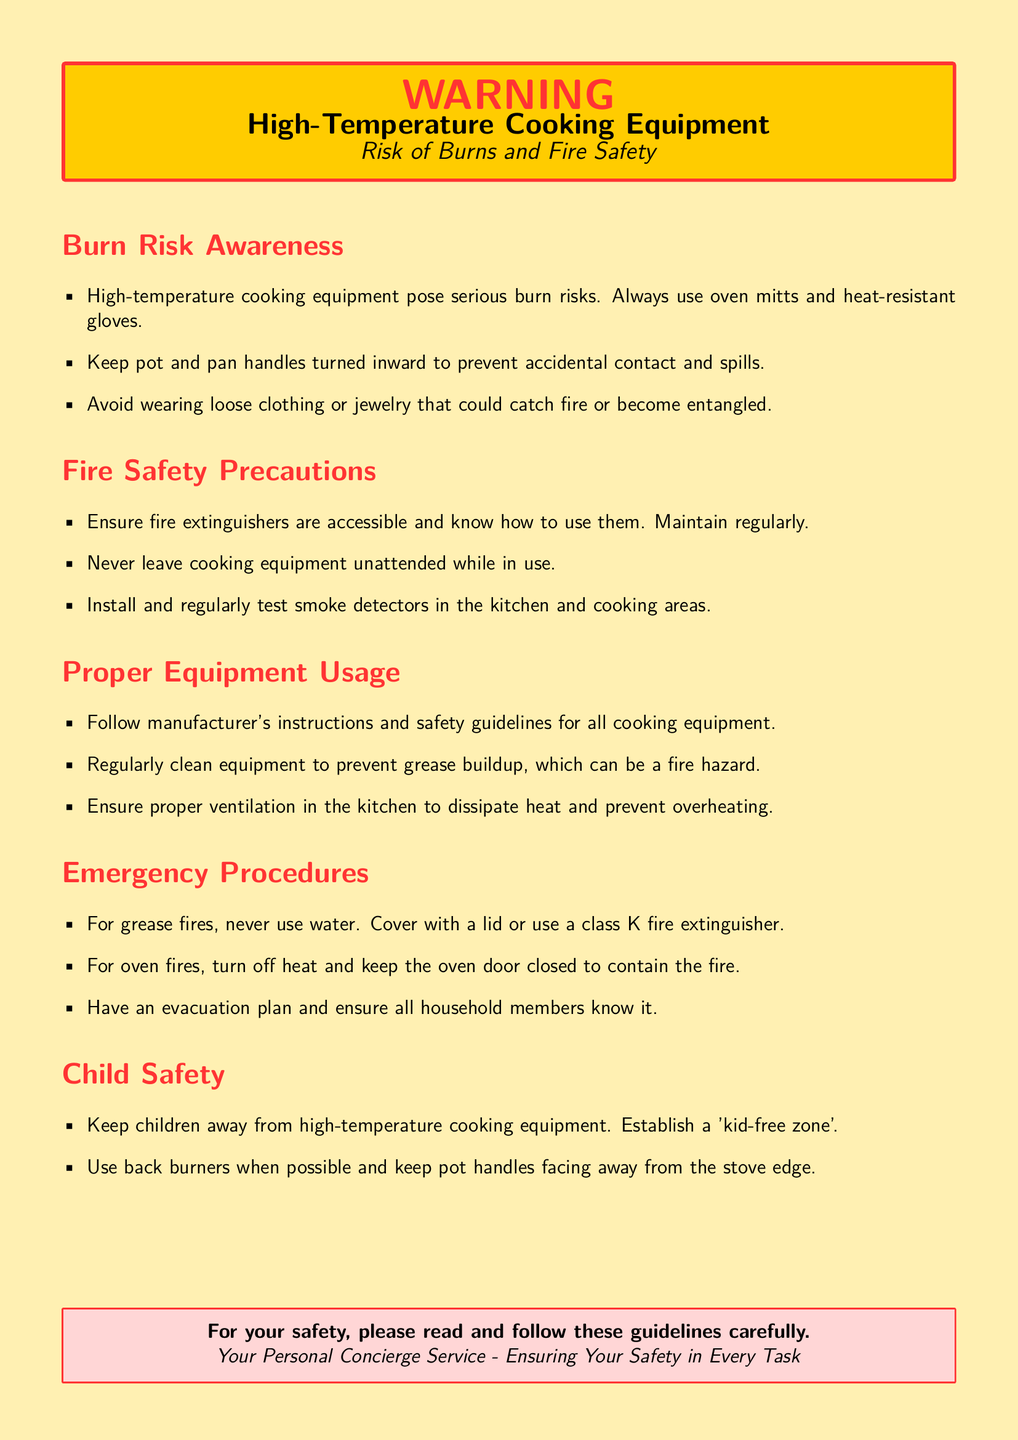What color is used for the warning box? The color used for the warning box is a shade of yellow, specifically a warning yellow.
Answer: warning yellow What should you never do with cooking equipment? The document states that you should never leave cooking equipment unattended while in use.
Answer: never leave cooking equipment unattended What type of fire extinguisher is recommended for grease fires? A class K fire extinguisher is recommended for grease fires according to the emergency procedures.
Answer: class K What is advised to keep children away from? The document advises to keep children away from high-temperature cooking equipment.
Answer: high-temperature cooking equipment How often should smoke detectors be tested? The document suggests that smoke detectors should be tested regularly.
Answer: regularly What should you establish for child safety? The document suggests establishing a 'kid-free zone' for child safety.
Answer: 'kid-free zone' What should pot and pan handles be turned to? The document states that pot and pan handles should be turned inward to prevent accidents.
Answer: inward What action should you take for an oven fire? The document instructs to turn off heat and keep the oven door closed for an oven fire.
Answer: turn off heat and keep oven door closed What is essential for fire safety in the cooking area? The presence of fire extinguishers that are accessible and properly maintained is essential for fire safety.
Answer: fire extinguishers accessible 